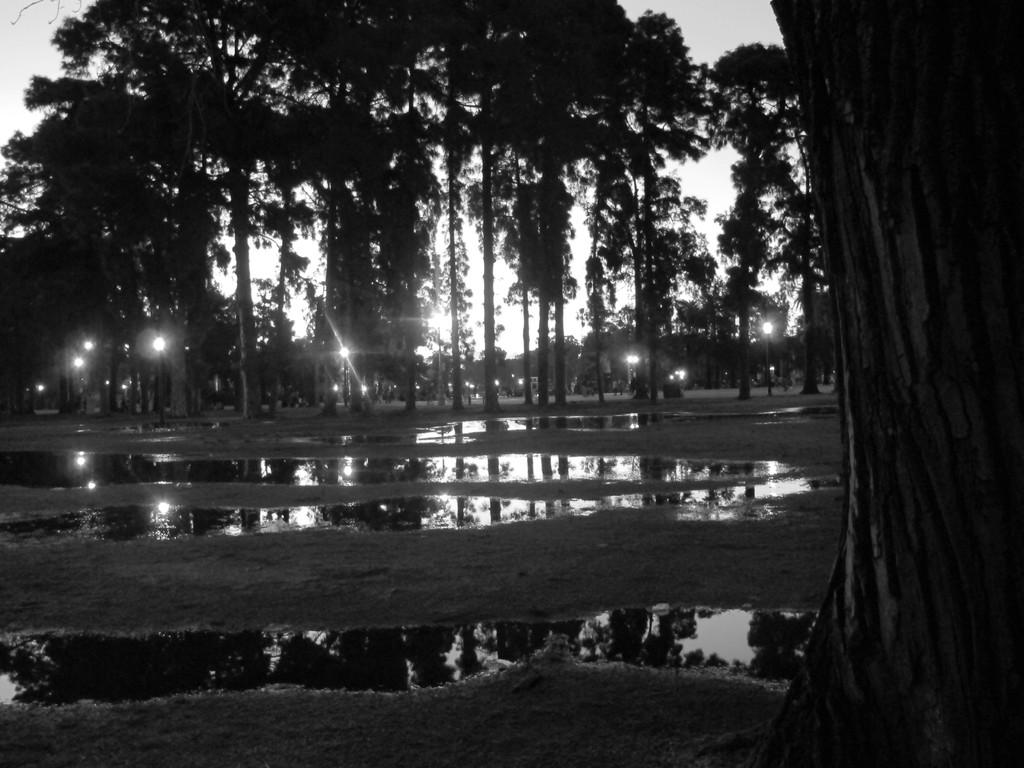What is located in the middle of the image? There is water in the middle of the image. What type of natural elements can be seen in the image? There are trees in the image. What type of artificial elements can be seen in the image? There are lights in the image. What is visible at the top of the image? The sky is visible at the top of the image. What is the profit margin of the trees in the image? There is no mention of profit or financial aspects in the image, as it features water, trees, lights, and a sky. Can you describe the detail of the attack on the water in the image? There is no attack or any indication of conflict in the image; it is a peaceful scene with water, trees, lights, and a sky. 